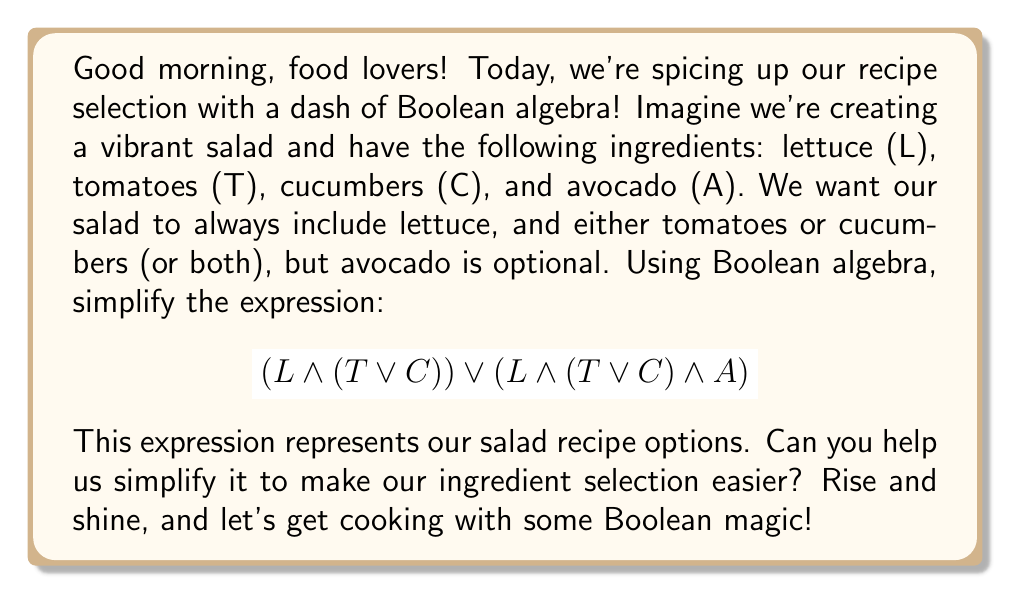Could you help me with this problem? Let's break this down step-by-step:

1) We start with the expression: $$(L \land (T \lor C)) \lor (L \land (T \lor C) \land A)$$

2) Let's focus on the common factor in both terms: $(L \land (T \lor C))$
   We can factor this out using the distributive law:

   $$(L \land (T \lor C)) \land (1 \lor A)$$

3) Now, let's simplify $(1 \lor A)$:
   In Boolean algebra, any value OR 1 is always 1.
   So, $(1 \lor A) = 1$

4) Our expression now becomes:

   $$(L \land (T \lor C)) \land 1$$

5) Anything AND 1 is just itself, so we can remove the $\land 1$:

   $$L \land (T \lor C)$$

This simplified expression means we must have lettuce (L) AND either tomatoes (T) OR cucumbers (C) (or both), which matches our original recipe requirements. The avocado (A) has been eliminated from the expression because it was optional and didn't affect the core recipe.
Answer: $$L \land (T \lor C)$$ 